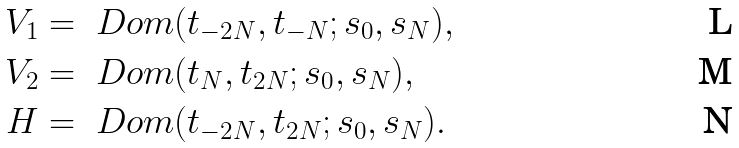Convert formula to latex. <formula><loc_0><loc_0><loc_500><loc_500>V _ { 1 } & = \ D o m ( t _ { - 2 N } , t _ { - N } ; s _ { 0 } , s _ { N } ) , \\ V _ { 2 } & = \ D o m ( t _ { N } , t _ { 2 N } ; s _ { 0 } , s _ { N } ) , \\ H & = \ D o m ( t _ { - 2 N } , t _ { 2 N } ; s _ { 0 } , s _ { N } ) .</formula> 